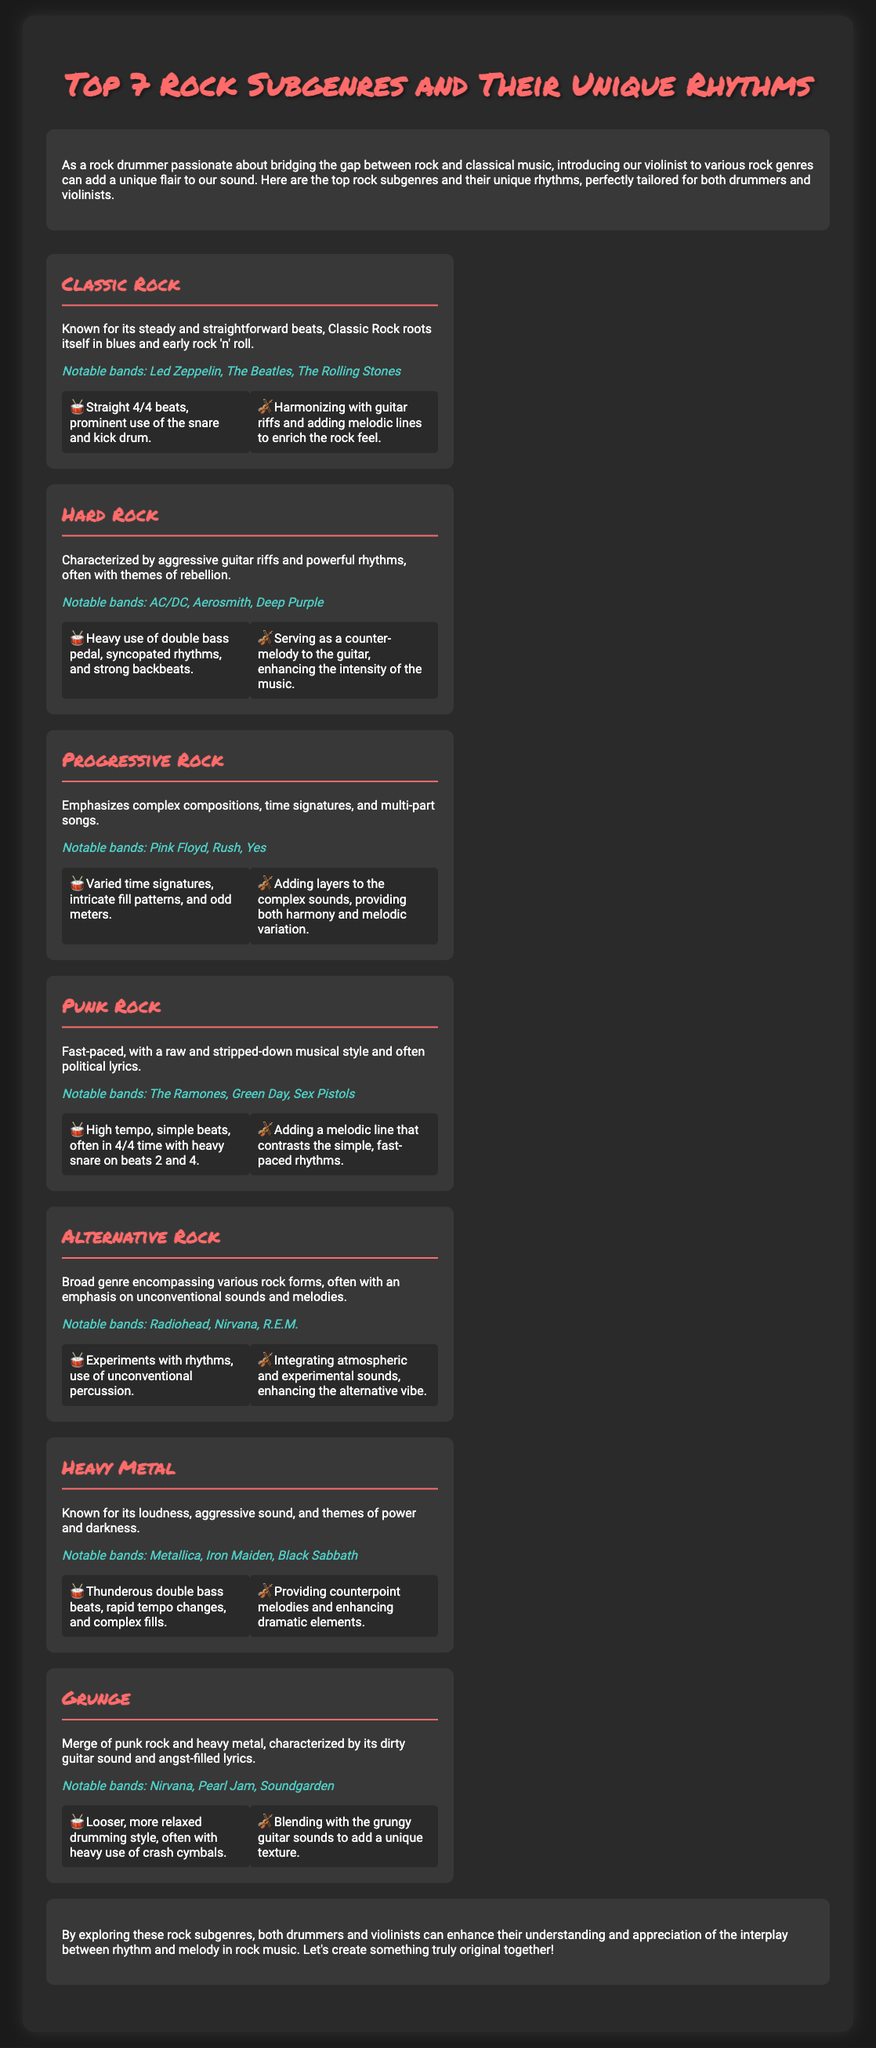What are the top seven rock subgenres mentioned? The document lists the top seven rock subgenres, which are Classic Rock, Hard Rock, Progressive Rock, Punk Rock, Alternative Rock, Heavy Metal, and Grunge.
Answer: Classic Rock, Hard Rock, Progressive Rock, Punk Rock, Alternative Rock, Heavy Metal, Grunge Which rock subgenre is known for its aggressive sound? The subgenre associated with an aggressive sound, loudness, and themes of power and darkness is Heavy Metal.
Answer: Heavy Metal What type of rhythm is characteristic of Punk Rock? Punk Rock is characterized by high tempo and simple beats, often in 4/4 time.
Answer: High tempo, simple beats Name a notable band for Progressive Rock. A notable band in the Progressive Rock genre is Pink Floyd.
Answer: Pink Floyd Which subgenre features harmonizing with guitar riffs? The subgenre where the violin harmonizes with guitar riffs is Classic Rock.
Answer: Classic Rock In which subgenre are fast-paced, raw lyrics commonly found? Fast-paced, raw and often political lyrics are commonly found in Punk Rock.
Answer: Punk Rock What unique element does the violin contribute to Hard Rock? In Hard Rock, the violin serves as a counter-melody to the guitar.
Answer: Counter-melody to the guitar How does the drumming style in Grunge differ from other subgenres? The drumming style in Grunge is described as looser and more relaxed, often with heavy use of crash cymbals.
Answer: Looser, relaxed drumming style Which subgenre emphasizes complex compositions and multiple time signatures? Progressive Rock emphasizes complex compositions and multi-part songs.
Answer: Progressive Rock 